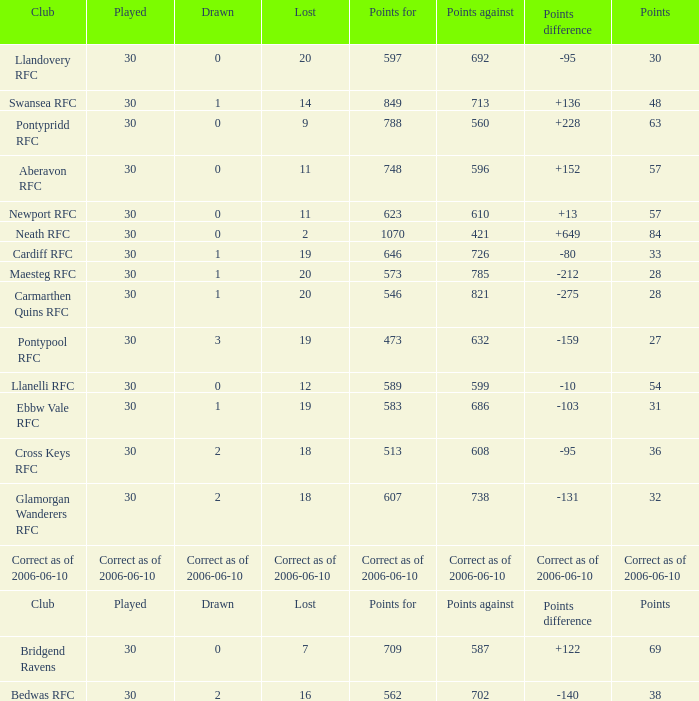What is Drawn, when Points Against is "686"? 1.0. 